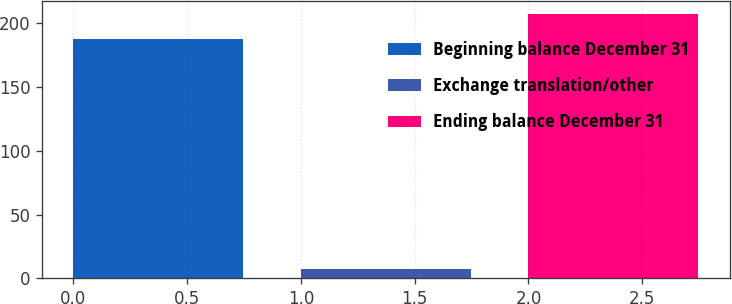Convert chart to OTSL. <chart><loc_0><loc_0><loc_500><loc_500><bar_chart><fcel>Beginning balance December 31<fcel>Exchange translation/other<fcel>Ending balance December 31<nl><fcel>188<fcel>7<fcel>207.5<nl></chart> 